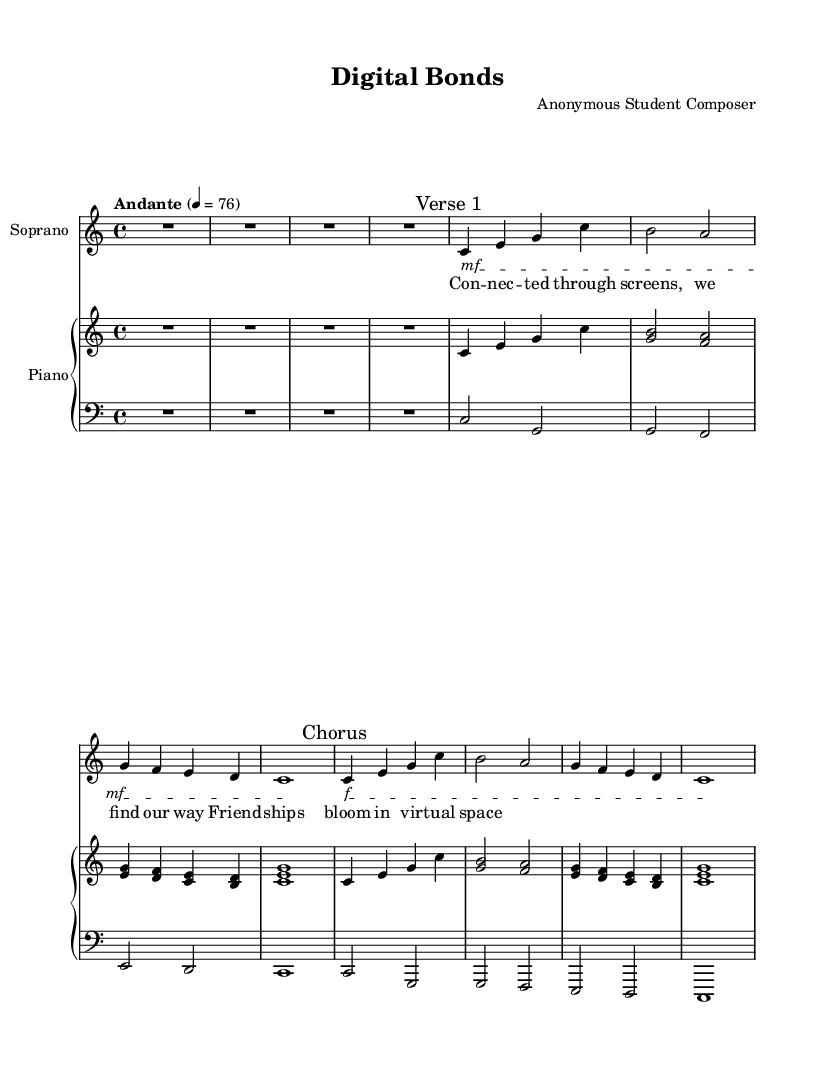What is the key signature of this music? The key signature is indicated by the lack of sharps or flats at the beginning of the staff. The absence of any accidentals confirms that the piece is in C major.
Answer: C major What is the time signature of this music? The time signature is visible at the beginning of the score, represented by the fraction "4/4." This means there are four beats in each measure, and the quarter note receives one beat.
Answer: 4/4 What is the tempo marking for this music? The tempo marking is written as "Andante" with a metronome marking of 76 beats per minute, which suggests a moderately slow pace.
Answer: Andante How many measures are in the introduction section? The introduction section has one measure, indicated by the "R1*4" marking, which denotes a rest for the whole measure (4 beats long).
Answer: 1 What dynamics are indicated for the chorus section? The dynamics marking for the chorus section displays "f," which stands for "forte," suggesting the music should be played loudly. This marking appears just before the start of the chorus.
Answer: f What is the main theme explored in the lyrics? The lyrics describe the theme of connecting through digital screens, highlighting the idea of friendships blossoming in virtual spaces, which underlies the entirety of the opera.
Answer: Digital connections How does the piano accompaniment support the lyrical content? The piano part provides harmonic support, with specific chord progressions that reinforce the lyrical themes, offering a harmonious background through the use of triads and bass notes that align with the vocal line, enhancing the emotional weight of the lyrics.
Answer: Harmonic support 